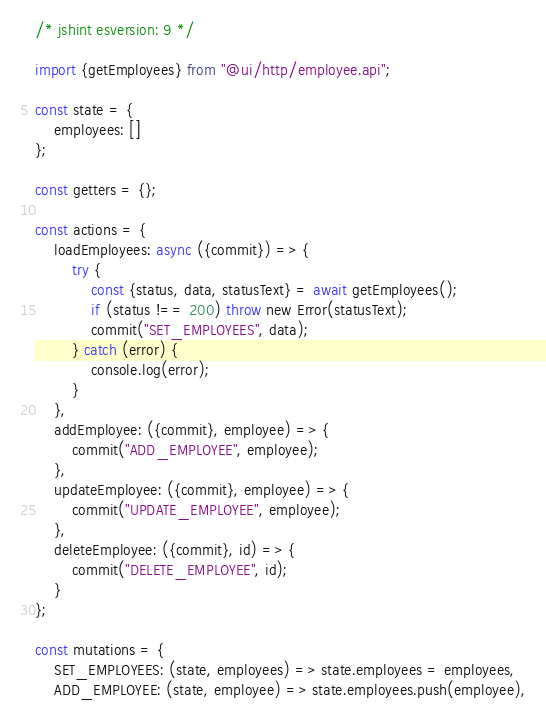<code> <loc_0><loc_0><loc_500><loc_500><_JavaScript_>/* jshint esversion: 9 */

import {getEmployees} from "@ui/http/employee.api";

const state = {
    employees: []
};

const getters = {};

const actions = {
    loadEmployees: async ({commit}) => {
        try {
            const {status, data, statusText} = await getEmployees();
            if (status !== 200) throw new Error(statusText);
            commit("SET_EMPLOYEES", data);
        } catch (error) {
            console.log(error);
        }
    },
    addEmployee: ({commit}, employee) => {
        commit("ADD_EMPLOYEE", employee);
    },
    updateEmployee: ({commit}, employee) => {
        commit("UPDATE_EMPLOYEE", employee);
    },
    deleteEmployee: ({commit}, id) => {
        commit("DELETE_EMPLOYEE", id);
    }
};

const mutations = {
    SET_EMPLOYEES: (state, employees) => state.employees = employees,
    ADD_EMPLOYEE: (state, employee) => state.employees.push(employee),</code> 